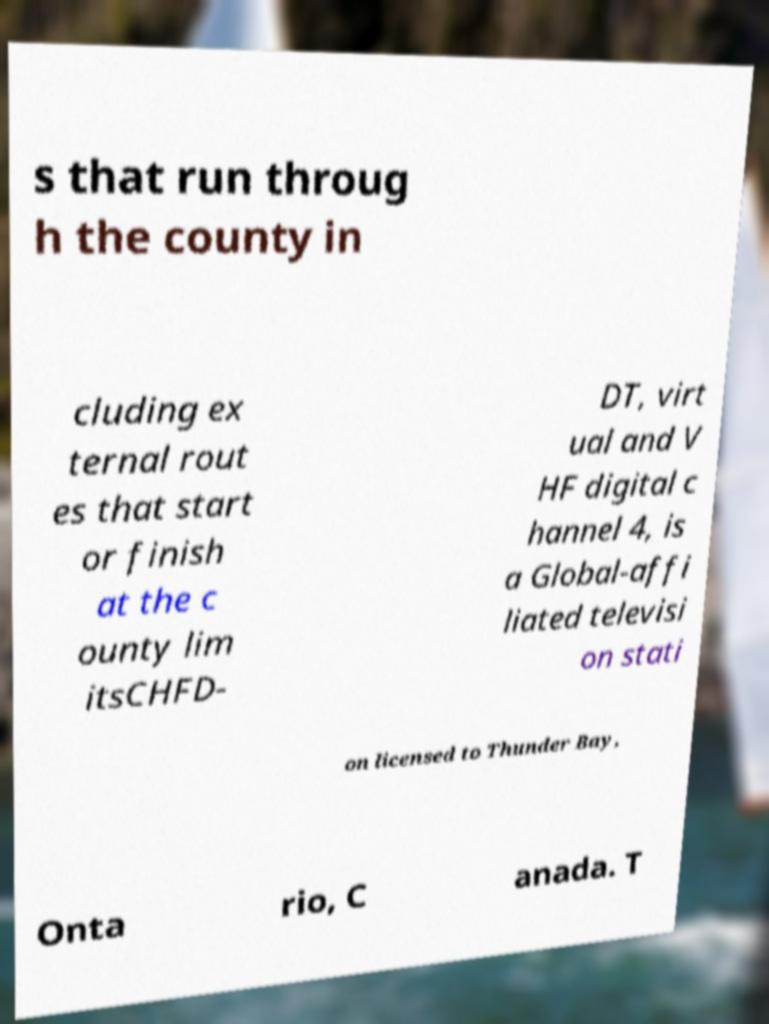Please read and relay the text visible in this image. What does it say? s that run throug h the county in cluding ex ternal rout es that start or finish at the c ounty lim itsCHFD- DT, virt ual and V HF digital c hannel 4, is a Global-affi liated televisi on stati on licensed to Thunder Bay, Onta rio, C anada. T 